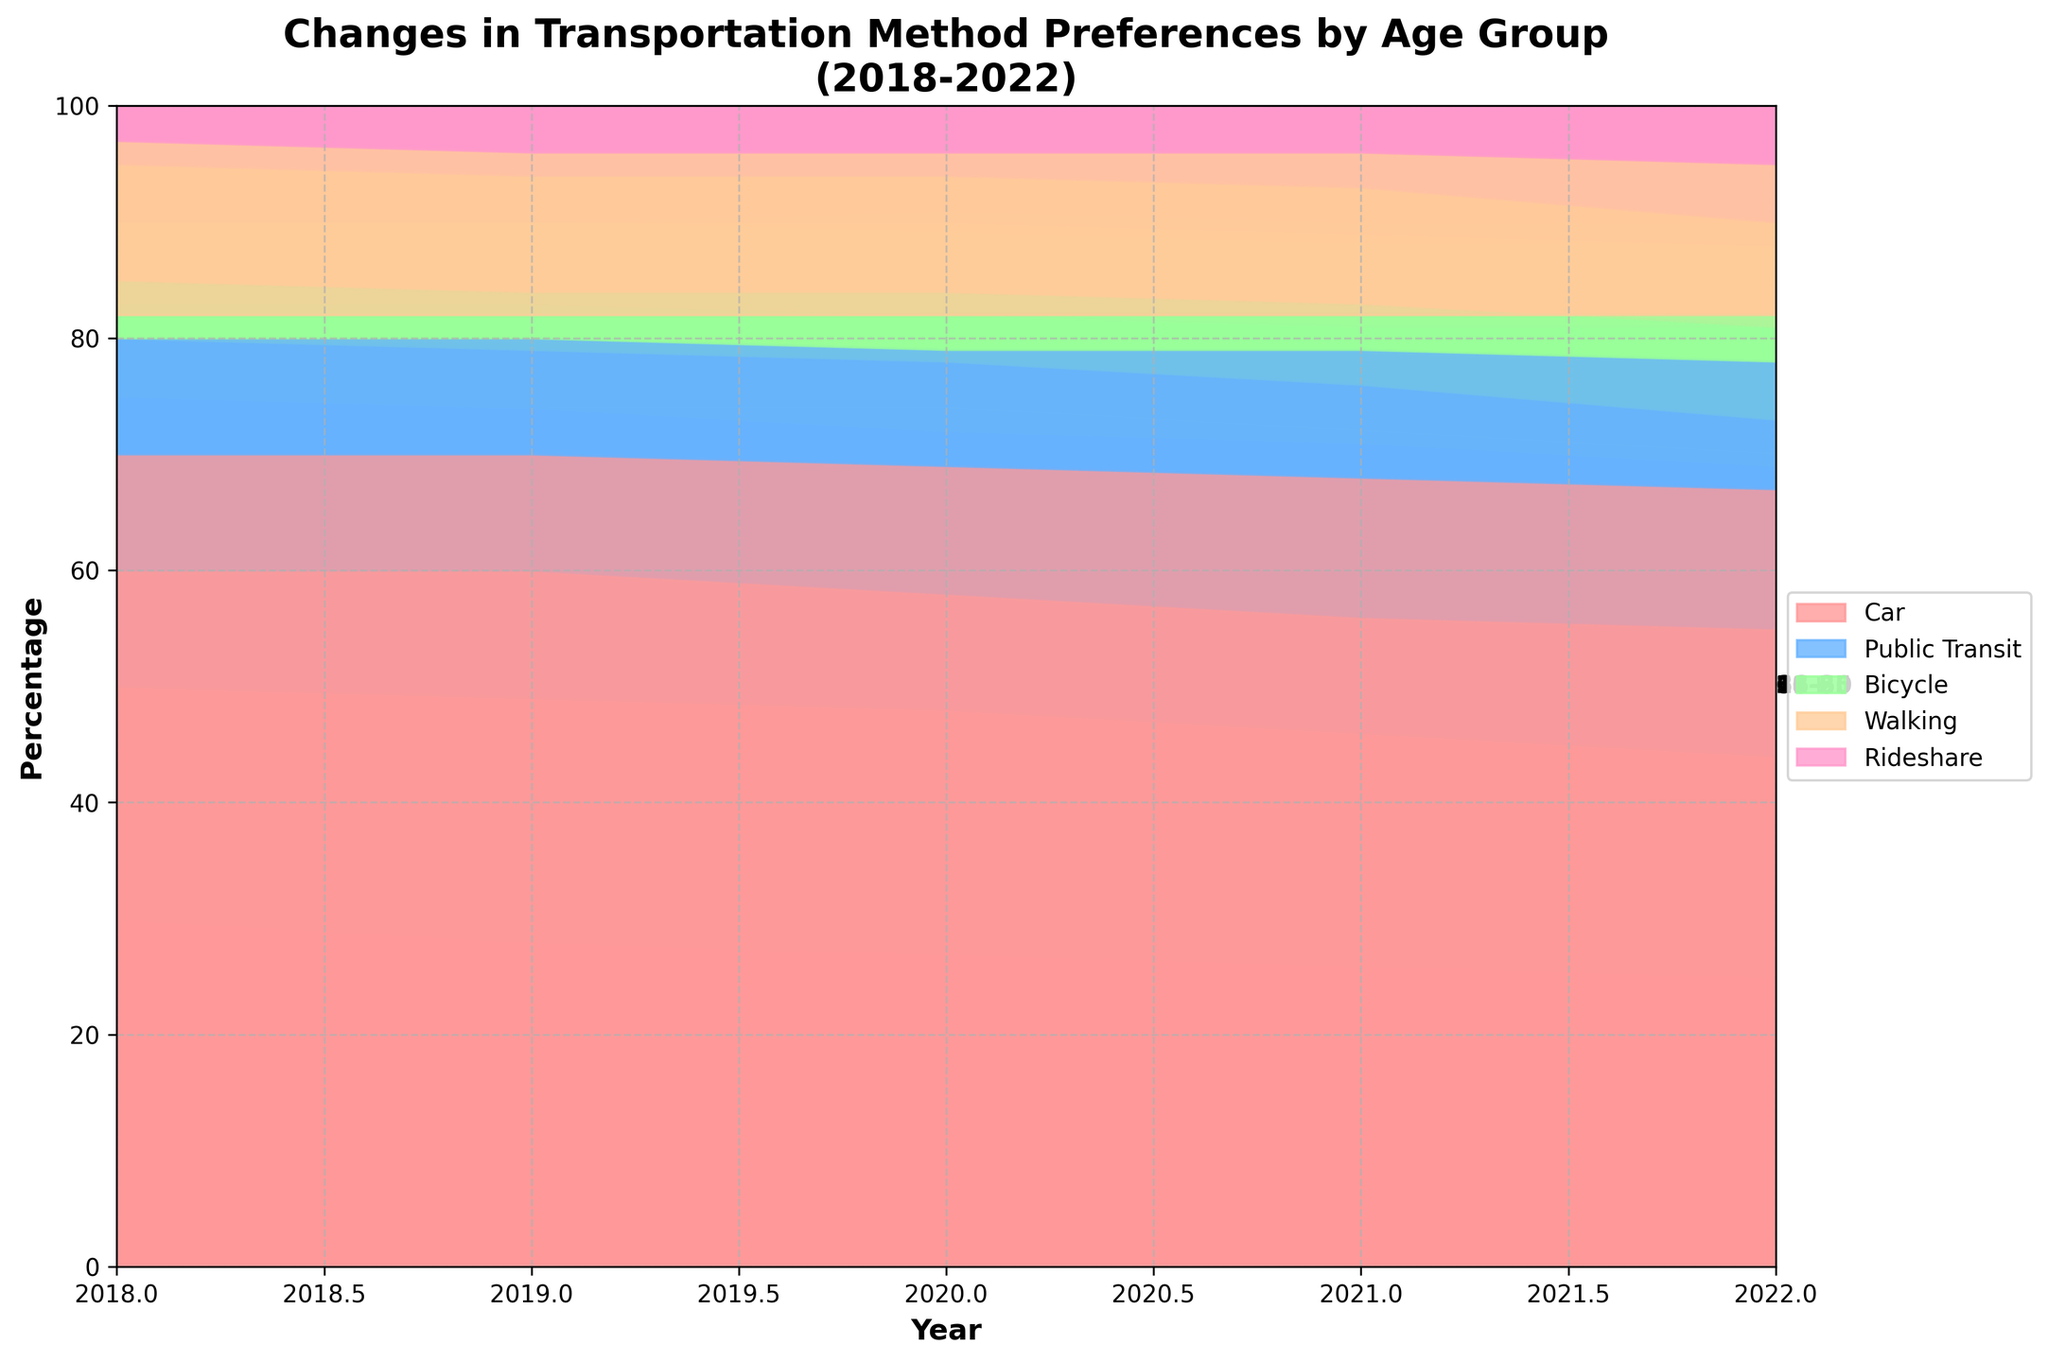what is the title of the chart? The title of the chart is located at the top of the figure and provides an overview of the chart's content
Answer: Changes in Transportation Method Preferences by Age Group (2018-2022) What percentage of people aged 66+ used a car in 2022? Look at the area representing the car for the 66+ age group in 2022, then refer to the y-axis to find the corresponding percentage.
Answer: 67% How did the preference for bicycles change for the 18-25 age group from 2018 to 2022? Find the area representing bicycles for the 18-25 age group at both 2018 and 2022, then compare their sizes to see the change.
Answer: Increased Which age group had the highest percentage using rideshare in 2022? Compare the areas representing rideshare for all age groups in 2022 and identify the one with the highest percentage.
Answer: 36-50 What trend is noticeable for public transit usage by the 26-35 age group from 2018 to 2022? Observe the area representing public transit for the 26-35 age group over the years from 2018 to 2022 to identify any noticeable trend.
Answer: Relatively stable Which transportation method saw the largest increase in percentage for the 51-65 age group from 2018 to 2022? Compare the changes in the areas representing different transportation methods for the 51-65 age group between 2018 and 2022 to find the one with the largest increase.
Answer: Rideshare What age group shows the most diversity in transportation methods in 2022? Observe the stacked areas for each age group in 2022 and identify the one with the most variety among different transportation methods.
Answer: 51-65 By how much did the percentage of people aged 18-25 using cars decrease from 2018 to 2022? Find the percentage of car usage for the 18-25 age group in both 2018 and 2022, then calculate the difference.
Answer: 5% Which age group relied most on walking in 2018? Compare the areas representing walking for all age groups in 2018 and identify the one with the highest percentage.
Answer: 66+ What is the overall trend in car usage for the 36-50 age group from 2018 to 2022? Observe the area representing car usage for the 36-50 age group over the years from 2018 to 2022 to identify the trend.
Answer: Decreasing 